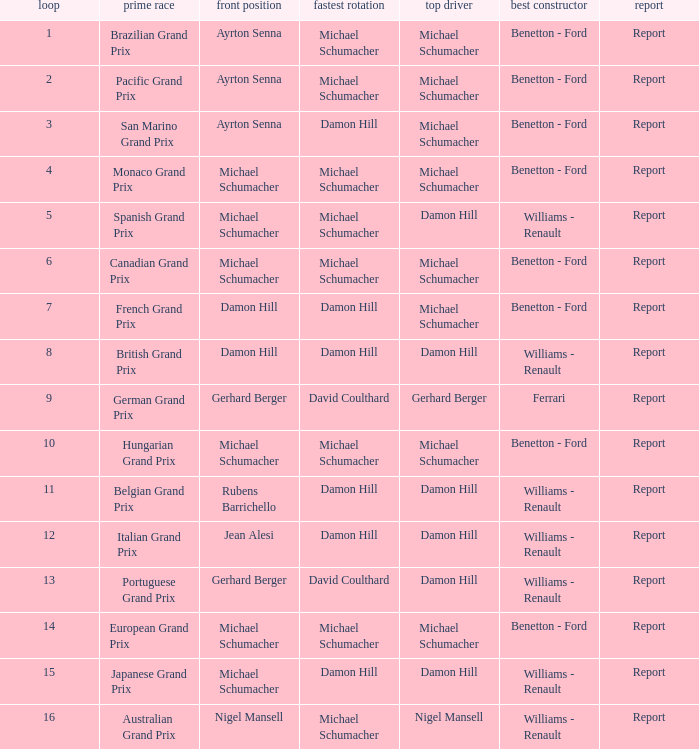Name the lowest round for when pole position and winning driver is michael schumacher 4.0. I'm looking to parse the entire table for insights. Could you assist me with that? {'header': ['loop', 'prime race', 'front position', 'fastest rotation', 'top driver', 'best constructor', 'report'], 'rows': [['1', 'Brazilian Grand Prix', 'Ayrton Senna', 'Michael Schumacher', 'Michael Schumacher', 'Benetton - Ford', 'Report'], ['2', 'Pacific Grand Prix', 'Ayrton Senna', 'Michael Schumacher', 'Michael Schumacher', 'Benetton - Ford', 'Report'], ['3', 'San Marino Grand Prix', 'Ayrton Senna', 'Damon Hill', 'Michael Schumacher', 'Benetton - Ford', 'Report'], ['4', 'Monaco Grand Prix', 'Michael Schumacher', 'Michael Schumacher', 'Michael Schumacher', 'Benetton - Ford', 'Report'], ['5', 'Spanish Grand Prix', 'Michael Schumacher', 'Michael Schumacher', 'Damon Hill', 'Williams - Renault', 'Report'], ['6', 'Canadian Grand Prix', 'Michael Schumacher', 'Michael Schumacher', 'Michael Schumacher', 'Benetton - Ford', 'Report'], ['7', 'French Grand Prix', 'Damon Hill', 'Damon Hill', 'Michael Schumacher', 'Benetton - Ford', 'Report'], ['8', 'British Grand Prix', 'Damon Hill', 'Damon Hill', 'Damon Hill', 'Williams - Renault', 'Report'], ['9', 'German Grand Prix', 'Gerhard Berger', 'David Coulthard', 'Gerhard Berger', 'Ferrari', 'Report'], ['10', 'Hungarian Grand Prix', 'Michael Schumacher', 'Michael Schumacher', 'Michael Schumacher', 'Benetton - Ford', 'Report'], ['11', 'Belgian Grand Prix', 'Rubens Barrichello', 'Damon Hill', 'Damon Hill', 'Williams - Renault', 'Report'], ['12', 'Italian Grand Prix', 'Jean Alesi', 'Damon Hill', 'Damon Hill', 'Williams - Renault', 'Report'], ['13', 'Portuguese Grand Prix', 'Gerhard Berger', 'David Coulthard', 'Damon Hill', 'Williams - Renault', 'Report'], ['14', 'European Grand Prix', 'Michael Schumacher', 'Michael Schumacher', 'Michael Schumacher', 'Benetton - Ford', 'Report'], ['15', 'Japanese Grand Prix', 'Michael Schumacher', 'Damon Hill', 'Damon Hill', 'Williams - Renault', 'Report'], ['16', 'Australian Grand Prix', 'Nigel Mansell', 'Michael Schumacher', 'Nigel Mansell', 'Williams - Renault', 'Report']]} 